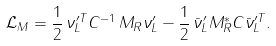<formula> <loc_0><loc_0><loc_500><loc_500>\mathcal { L } _ { M } = \frac { 1 } { 2 } \, \nu ^ { \prime T } _ { L } C ^ { - 1 } \, M _ { R } \nu ^ { \prime } _ { L } - \frac { 1 } { 2 } \, \bar { \nu } ^ { \prime } _ { L } M _ { R } ^ { * } C { \bar { \nu } } _ { L } ^ { \prime T } .</formula> 